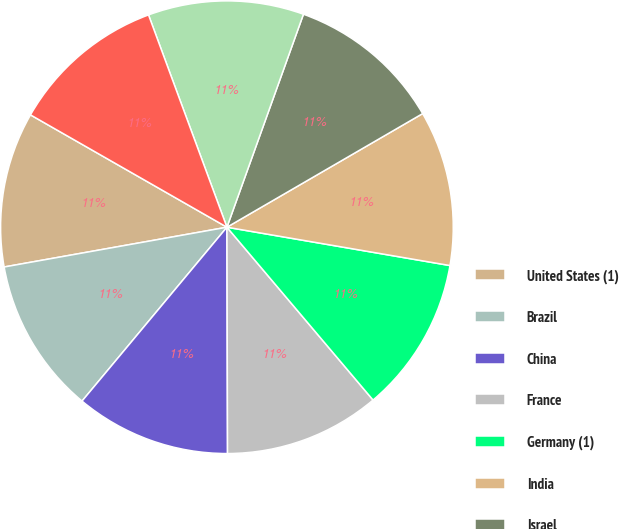Convert chart to OTSL. <chart><loc_0><loc_0><loc_500><loc_500><pie_chart><fcel>United States (1)<fcel>Brazil<fcel>China<fcel>France<fcel>Germany (1)<fcel>India<fcel>Israel<fcel>Japan<fcel>United Kingdom<nl><fcel>11.08%<fcel>11.13%<fcel>11.1%<fcel>11.13%<fcel>11.12%<fcel>11.08%<fcel>11.14%<fcel>11.12%<fcel>11.1%<nl></chart> 